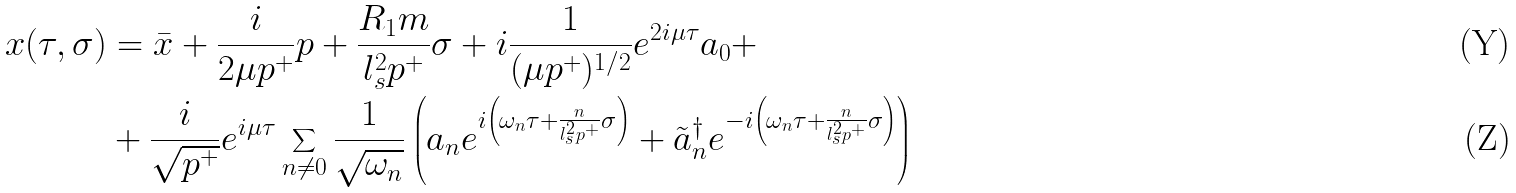Convert formula to latex. <formula><loc_0><loc_0><loc_500><loc_500>x ( \tau , \sigma ) & = \bar { x } + \frac { i } { 2 \mu p ^ { + } } p + \frac { R _ { 1 } m } { l _ { s } ^ { 2 } p ^ { + } } \sigma + i \frac { 1 } { ( \mu p ^ { + } ) ^ { 1 / 2 } } e ^ { 2 i \mu \tau } a _ { 0 } + \\ & + \frac { i } { \sqrt { p ^ { + } } } e ^ { i \mu \tau } \sum _ { n \neq 0 } \frac { 1 } { \sqrt { \omega _ { n } } } \left ( a _ { n } e ^ { i \left ( \omega _ { n } \tau + \frac { n } { l _ { s } ^ { 2 } p ^ { + } } \sigma \right ) } + { \tilde { a } _ { n } } ^ { \dagger } e ^ { - i \left ( \omega _ { n } \tau + \frac { n } { l _ { s } ^ { 2 } p ^ { + } } \sigma \right ) } \right )</formula> 